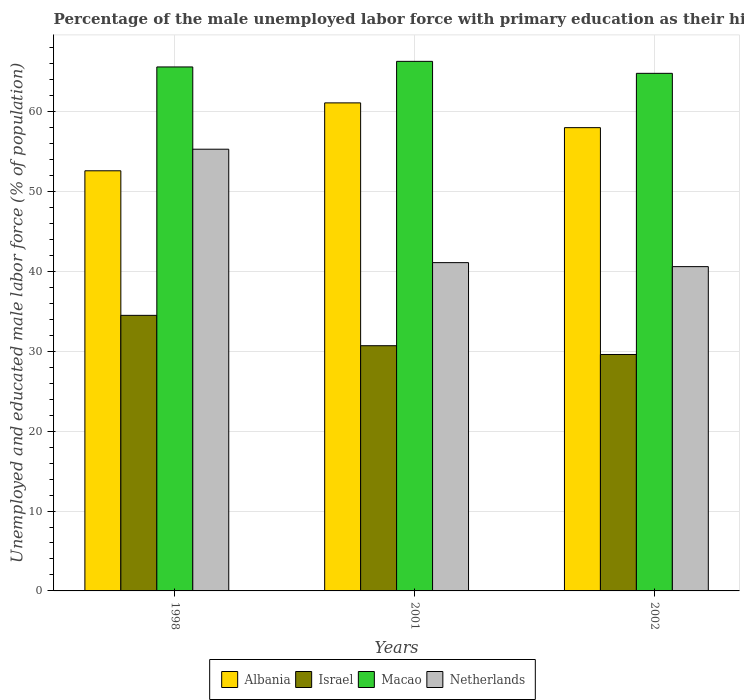How many groups of bars are there?
Your answer should be very brief. 3. Are the number of bars on each tick of the X-axis equal?
Provide a short and direct response. Yes. How many bars are there on the 1st tick from the left?
Your answer should be very brief. 4. What is the label of the 1st group of bars from the left?
Keep it short and to the point. 1998. In how many cases, is the number of bars for a given year not equal to the number of legend labels?
Offer a terse response. 0. What is the percentage of the unemployed male labor force with primary education in Macao in 1998?
Offer a terse response. 65.6. Across all years, what is the maximum percentage of the unemployed male labor force with primary education in Macao?
Your response must be concise. 66.3. Across all years, what is the minimum percentage of the unemployed male labor force with primary education in Israel?
Ensure brevity in your answer.  29.6. In which year was the percentage of the unemployed male labor force with primary education in Macao maximum?
Ensure brevity in your answer.  2001. In which year was the percentage of the unemployed male labor force with primary education in Albania minimum?
Keep it short and to the point. 1998. What is the total percentage of the unemployed male labor force with primary education in Israel in the graph?
Provide a short and direct response. 94.8. What is the difference between the percentage of the unemployed male labor force with primary education in Macao in 1998 and that in 2002?
Your response must be concise. 0.8. What is the difference between the percentage of the unemployed male labor force with primary education in Israel in 1998 and the percentage of the unemployed male labor force with primary education in Albania in 2001?
Keep it short and to the point. -26.6. What is the average percentage of the unemployed male labor force with primary education in Albania per year?
Make the answer very short. 57.23. In the year 1998, what is the difference between the percentage of the unemployed male labor force with primary education in Netherlands and percentage of the unemployed male labor force with primary education in Israel?
Offer a terse response. 20.8. In how many years, is the percentage of the unemployed male labor force with primary education in Macao greater than 30 %?
Keep it short and to the point. 3. What is the ratio of the percentage of the unemployed male labor force with primary education in Albania in 1998 to that in 2002?
Make the answer very short. 0.91. What is the difference between the highest and the second highest percentage of the unemployed male labor force with primary education in Albania?
Your answer should be compact. 3.1. What is the difference between the highest and the lowest percentage of the unemployed male labor force with primary education in Macao?
Offer a very short reply. 1.5. In how many years, is the percentage of the unemployed male labor force with primary education in Netherlands greater than the average percentage of the unemployed male labor force with primary education in Netherlands taken over all years?
Your response must be concise. 1. Is the sum of the percentage of the unemployed male labor force with primary education in Macao in 1998 and 2002 greater than the maximum percentage of the unemployed male labor force with primary education in Netherlands across all years?
Provide a succinct answer. Yes. Is it the case that in every year, the sum of the percentage of the unemployed male labor force with primary education in Macao and percentage of the unemployed male labor force with primary education in Israel is greater than the sum of percentage of the unemployed male labor force with primary education in Netherlands and percentage of the unemployed male labor force with primary education in Albania?
Ensure brevity in your answer.  Yes. What does the 1st bar from the left in 2001 represents?
Provide a short and direct response. Albania. What does the 2nd bar from the right in 2002 represents?
Make the answer very short. Macao. Is it the case that in every year, the sum of the percentage of the unemployed male labor force with primary education in Netherlands and percentage of the unemployed male labor force with primary education in Albania is greater than the percentage of the unemployed male labor force with primary education in Macao?
Make the answer very short. Yes. How many bars are there?
Your answer should be very brief. 12. How many years are there in the graph?
Offer a very short reply. 3. Does the graph contain any zero values?
Your answer should be compact. No. Does the graph contain grids?
Provide a succinct answer. Yes. Where does the legend appear in the graph?
Make the answer very short. Bottom center. How many legend labels are there?
Provide a succinct answer. 4. What is the title of the graph?
Provide a succinct answer. Percentage of the male unemployed labor force with primary education as their highest grade. Does "Togo" appear as one of the legend labels in the graph?
Your answer should be compact. No. What is the label or title of the X-axis?
Offer a terse response. Years. What is the label or title of the Y-axis?
Give a very brief answer. Unemployed and educated male labor force (% of population). What is the Unemployed and educated male labor force (% of population) of Albania in 1998?
Your answer should be compact. 52.6. What is the Unemployed and educated male labor force (% of population) in Israel in 1998?
Your answer should be compact. 34.5. What is the Unemployed and educated male labor force (% of population) of Macao in 1998?
Your answer should be compact. 65.6. What is the Unemployed and educated male labor force (% of population) in Netherlands in 1998?
Offer a terse response. 55.3. What is the Unemployed and educated male labor force (% of population) of Albania in 2001?
Keep it short and to the point. 61.1. What is the Unemployed and educated male labor force (% of population) in Israel in 2001?
Offer a very short reply. 30.7. What is the Unemployed and educated male labor force (% of population) in Macao in 2001?
Offer a very short reply. 66.3. What is the Unemployed and educated male labor force (% of population) in Netherlands in 2001?
Your response must be concise. 41.1. What is the Unemployed and educated male labor force (% of population) of Albania in 2002?
Offer a very short reply. 58. What is the Unemployed and educated male labor force (% of population) of Israel in 2002?
Ensure brevity in your answer.  29.6. What is the Unemployed and educated male labor force (% of population) of Macao in 2002?
Provide a short and direct response. 64.8. What is the Unemployed and educated male labor force (% of population) of Netherlands in 2002?
Give a very brief answer. 40.6. Across all years, what is the maximum Unemployed and educated male labor force (% of population) in Albania?
Provide a succinct answer. 61.1. Across all years, what is the maximum Unemployed and educated male labor force (% of population) in Israel?
Ensure brevity in your answer.  34.5. Across all years, what is the maximum Unemployed and educated male labor force (% of population) of Macao?
Your answer should be compact. 66.3. Across all years, what is the maximum Unemployed and educated male labor force (% of population) in Netherlands?
Offer a very short reply. 55.3. Across all years, what is the minimum Unemployed and educated male labor force (% of population) of Albania?
Your answer should be compact. 52.6. Across all years, what is the minimum Unemployed and educated male labor force (% of population) of Israel?
Give a very brief answer. 29.6. Across all years, what is the minimum Unemployed and educated male labor force (% of population) of Macao?
Offer a very short reply. 64.8. Across all years, what is the minimum Unemployed and educated male labor force (% of population) of Netherlands?
Make the answer very short. 40.6. What is the total Unemployed and educated male labor force (% of population) of Albania in the graph?
Keep it short and to the point. 171.7. What is the total Unemployed and educated male labor force (% of population) in Israel in the graph?
Your answer should be very brief. 94.8. What is the total Unemployed and educated male labor force (% of population) of Macao in the graph?
Give a very brief answer. 196.7. What is the total Unemployed and educated male labor force (% of population) of Netherlands in the graph?
Keep it short and to the point. 137. What is the difference between the Unemployed and educated male labor force (% of population) of Israel in 1998 and that in 2001?
Your response must be concise. 3.8. What is the difference between the Unemployed and educated male labor force (% of population) in Macao in 1998 and that in 2001?
Keep it short and to the point. -0.7. What is the difference between the Unemployed and educated male labor force (% of population) in Netherlands in 1998 and that in 2001?
Make the answer very short. 14.2. What is the difference between the Unemployed and educated male labor force (% of population) in Albania in 1998 and that in 2002?
Provide a succinct answer. -5.4. What is the difference between the Unemployed and educated male labor force (% of population) in Netherlands in 2001 and that in 2002?
Your answer should be very brief. 0.5. What is the difference between the Unemployed and educated male labor force (% of population) of Albania in 1998 and the Unemployed and educated male labor force (% of population) of Israel in 2001?
Ensure brevity in your answer.  21.9. What is the difference between the Unemployed and educated male labor force (% of population) in Albania in 1998 and the Unemployed and educated male labor force (% of population) in Macao in 2001?
Ensure brevity in your answer.  -13.7. What is the difference between the Unemployed and educated male labor force (% of population) of Albania in 1998 and the Unemployed and educated male labor force (% of population) of Netherlands in 2001?
Ensure brevity in your answer.  11.5. What is the difference between the Unemployed and educated male labor force (% of population) in Israel in 1998 and the Unemployed and educated male labor force (% of population) in Macao in 2001?
Ensure brevity in your answer.  -31.8. What is the difference between the Unemployed and educated male labor force (% of population) of Albania in 1998 and the Unemployed and educated male labor force (% of population) of Israel in 2002?
Give a very brief answer. 23. What is the difference between the Unemployed and educated male labor force (% of population) of Israel in 1998 and the Unemployed and educated male labor force (% of population) of Macao in 2002?
Ensure brevity in your answer.  -30.3. What is the difference between the Unemployed and educated male labor force (% of population) in Albania in 2001 and the Unemployed and educated male labor force (% of population) in Israel in 2002?
Your response must be concise. 31.5. What is the difference between the Unemployed and educated male labor force (% of population) of Albania in 2001 and the Unemployed and educated male labor force (% of population) of Macao in 2002?
Provide a succinct answer. -3.7. What is the difference between the Unemployed and educated male labor force (% of population) of Israel in 2001 and the Unemployed and educated male labor force (% of population) of Macao in 2002?
Provide a short and direct response. -34.1. What is the difference between the Unemployed and educated male labor force (% of population) in Macao in 2001 and the Unemployed and educated male labor force (% of population) in Netherlands in 2002?
Keep it short and to the point. 25.7. What is the average Unemployed and educated male labor force (% of population) in Albania per year?
Ensure brevity in your answer.  57.23. What is the average Unemployed and educated male labor force (% of population) in Israel per year?
Make the answer very short. 31.6. What is the average Unemployed and educated male labor force (% of population) in Macao per year?
Your answer should be compact. 65.57. What is the average Unemployed and educated male labor force (% of population) of Netherlands per year?
Keep it short and to the point. 45.67. In the year 1998, what is the difference between the Unemployed and educated male labor force (% of population) of Albania and Unemployed and educated male labor force (% of population) of Macao?
Your response must be concise. -13. In the year 1998, what is the difference between the Unemployed and educated male labor force (% of population) of Albania and Unemployed and educated male labor force (% of population) of Netherlands?
Keep it short and to the point. -2.7. In the year 1998, what is the difference between the Unemployed and educated male labor force (% of population) of Israel and Unemployed and educated male labor force (% of population) of Macao?
Your answer should be very brief. -31.1. In the year 1998, what is the difference between the Unemployed and educated male labor force (% of population) of Israel and Unemployed and educated male labor force (% of population) of Netherlands?
Ensure brevity in your answer.  -20.8. In the year 1998, what is the difference between the Unemployed and educated male labor force (% of population) of Macao and Unemployed and educated male labor force (% of population) of Netherlands?
Make the answer very short. 10.3. In the year 2001, what is the difference between the Unemployed and educated male labor force (% of population) in Albania and Unemployed and educated male labor force (% of population) in Israel?
Offer a terse response. 30.4. In the year 2001, what is the difference between the Unemployed and educated male labor force (% of population) of Albania and Unemployed and educated male labor force (% of population) of Macao?
Your answer should be compact. -5.2. In the year 2001, what is the difference between the Unemployed and educated male labor force (% of population) in Albania and Unemployed and educated male labor force (% of population) in Netherlands?
Ensure brevity in your answer.  20. In the year 2001, what is the difference between the Unemployed and educated male labor force (% of population) in Israel and Unemployed and educated male labor force (% of population) in Macao?
Make the answer very short. -35.6. In the year 2001, what is the difference between the Unemployed and educated male labor force (% of population) of Macao and Unemployed and educated male labor force (% of population) of Netherlands?
Keep it short and to the point. 25.2. In the year 2002, what is the difference between the Unemployed and educated male labor force (% of population) of Albania and Unemployed and educated male labor force (% of population) of Israel?
Your response must be concise. 28.4. In the year 2002, what is the difference between the Unemployed and educated male labor force (% of population) of Albania and Unemployed and educated male labor force (% of population) of Macao?
Ensure brevity in your answer.  -6.8. In the year 2002, what is the difference between the Unemployed and educated male labor force (% of population) in Albania and Unemployed and educated male labor force (% of population) in Netherlands?
Make the answer very short. 17.4. In the year 2002, what is the difference between the Unemployed and educated male labor force (% of population) of Israel and Unemployed and educated male labor force (% of population) of Macao?
Your response must be concise. -35.2. In the year 2002, what is the difference between the Unemployed and educated male labor force (% of population) in Macao and Unemployed and educated male labor force (% of population) in Netherlands?
Offer a terse response. 24.2. What is the ratio of the Unemployed and educated male labor force (% of population) in Albania in 1998 to that in 2001?
Ensure brevity in your answer.  0.86. What is the ratio of the Unemployed and educated male labor force (% of population) in Israel in 1998 to that in 2001?
Ensure brevity in your answer.  1.12. What is the ratio of the Unemployed and educated male labor force (% of population) in Netherlands in 1998 to that in 2001?
Ensure brevity in your answer.  1.35. What is the ratio of the Unemployed and educated male labor force (% of population) of Albania in 1998 to that in 2002?
Give a very brief answer. 0.91. What is the ratio of the Unemployed and educated male labor force (% of population) of Israel in 1998 to that in 2002?
Your answer should be very brief. 1.17. What is the ratio of the Unemployed and educated male labor force (% of population) of Macao in 1998 to that in 2002?
Ensure brevity in your answer.  1.01. What is the ratio of the Unemployed and educated male labor force (% of population) in Netherlands in 1998 to that in 2002?
Provide a succinct answer. 1.36. What is the ratio of the Unemployed and educated male labor force (% of population) of Albania in 2001 to that in 2002?
Your answer should be very brief. 1.05. What is the ratio of the Unemployed and educated male labor force (% of population) of Israel in 2001 to that in 2002?
Make the answer very short. 1.04. What is the ratio of the Unemployed and educated male labor force (% of population) in Macao in 2001 to that in 2002?
Make the answer very short. 1.02. What is the ratio of the Unemployed and educated male labor force (% of population) of Netherlands in 2001 to that in 2002?
Keep it short and to the point. 1.01. What is the difference between the highest and the second highest Unemployed and educated male labor force (% of population) in Albania?
Ensure brevity in your answer.  3.1. What is the difference between the highest and the second highest Unemployed and educated male labor force (% of population) in Israel?
Your answer should be compact. 3.8. What is the difference between the highest and the second highest Unemployed and educated male labor force (% of population) of Netherlands?
Your answer should be very brief. 14.2. What is the difference between the highest and the lowest Unemployed and educated male labor force (% of population) of Albania?
Give a very brief answer. 8.5. 